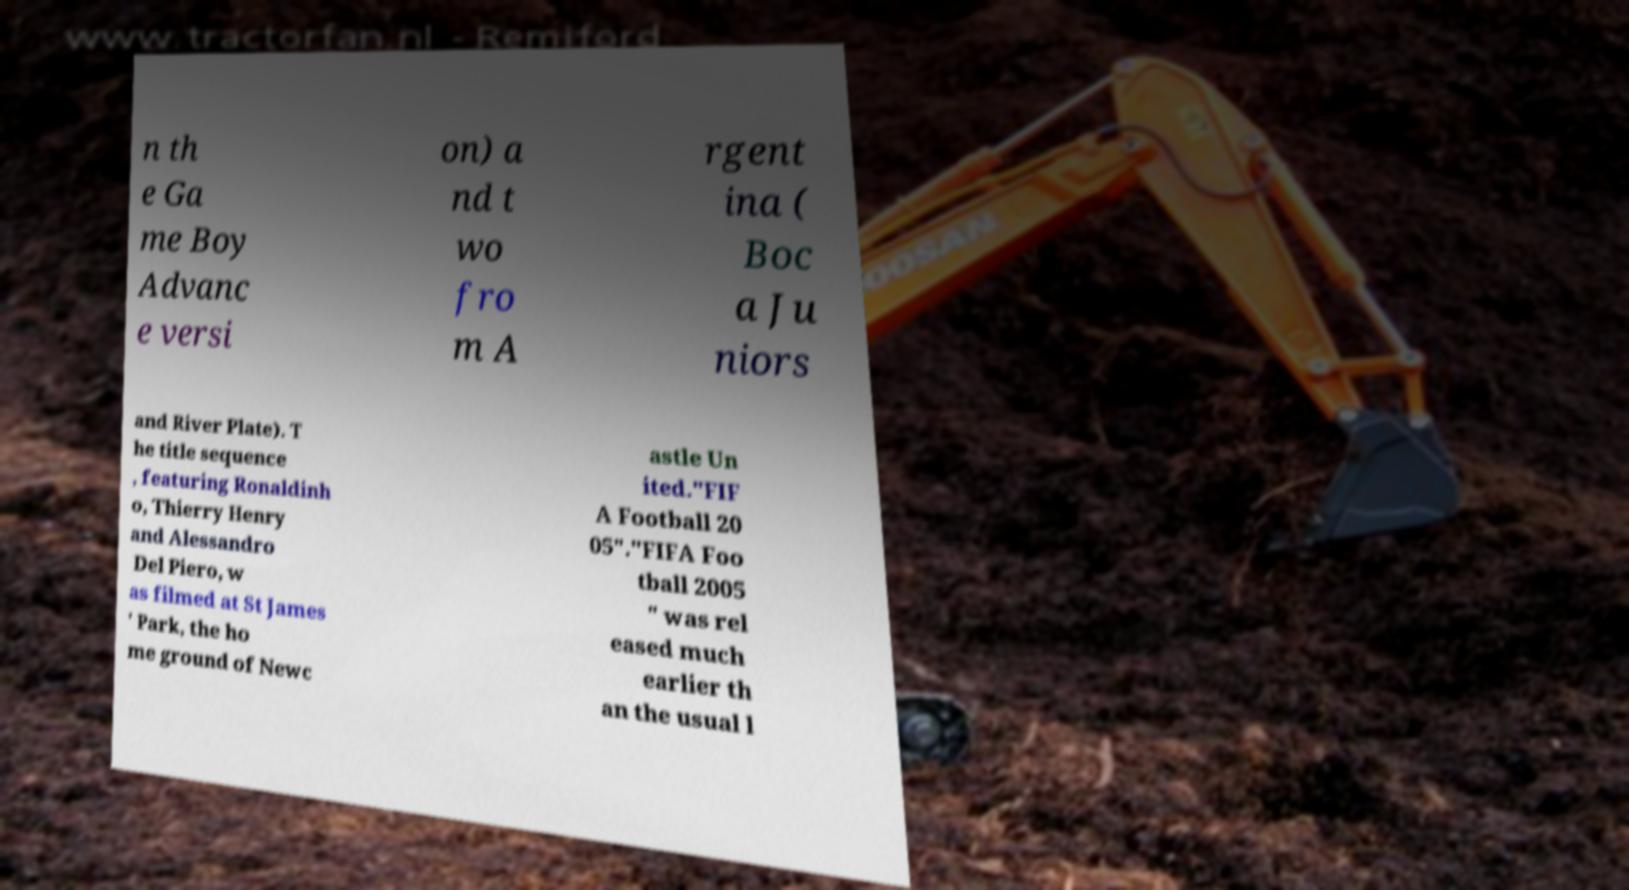Can you accurately transcribe the text from the provided image for me? n th e Ga me Boy Advanc e versi on) a nd t wo fro m A rgent ina ( Boc a Ju niors and River Plate). T he title sequence , featuring Ronaldinh o, Thierry Henry and Alessandro Del Piero, w as filmed at St James ' Park, the ho me ground of Newc astle Un ited."FIF A Football 20 05"."FIFA Foo tball 2005 " was rel eased much earlier th an the usual l 